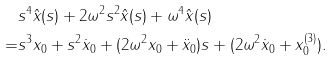Convert formula to latex. <formula><loc_0><loc_0><loc_500><loc_500>& s ^ { 4 } \hat { x } ( s ) + 2 \omega ^ { 2 } s ^ { 2 } \hat { x } ( s ) + \omega ^ { 4 } \hat { x } ( s ) \\ = & s ^ { 3 } x _ { 0 } + s ^ { 2 } \dot { x } _ { 0 } + ( 2 \omega ^ { 2 } { x } _ { 0 } + \ddot { x } _ { 0 } ) s + ( 2 \omega ^ { 2 } \dot { x } _ { 0 } + x ^ { ( 3 ) } _ { 0 } ) .</formula> 